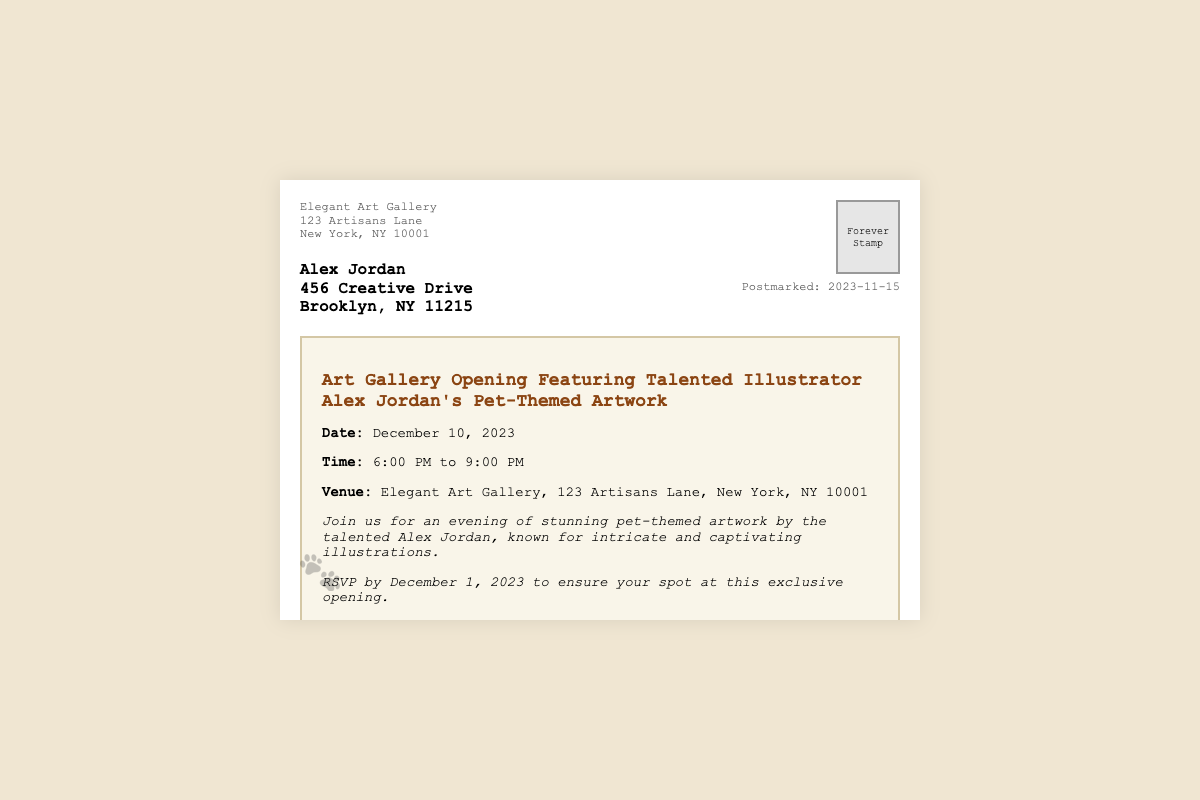What is the name of the recipient? The recipient's name is clearly stated in the document.
Answer: Alex Jordan What is the date of the art gallery opening? The document specifies the date of the event.
Answer: December 10, 2023 What time does the event start? The document provides the starting and ending times of the event.
Answer: 6:00 PM What is the location of the Elegant Art Gallery? The address of the gallery is mentioned in the invitation section.
Answer: 123 Artisans Lane, New York, NY 10001 What should guests RSVP by? The document mentions the date by which attendees should confirm their attendance.
Answer: December 1, 2023 What type of artwork is featured in the gallery opening? The invitation specifies the nature of the artwork being showcased.
Answer: Pet-themed artwork What refreshments will be served at the event? The extra information section mentions what will be available at the event.
Answer: Cocktails and light refreshments Who is the sender of the invitation? The sender's name and organization are listed at the top of the document.
Answer: Elegant Art Gallery Which email address can be used for inquiries? The document provides contact information for further questions.
Answer: info@elegantartgallery.com 